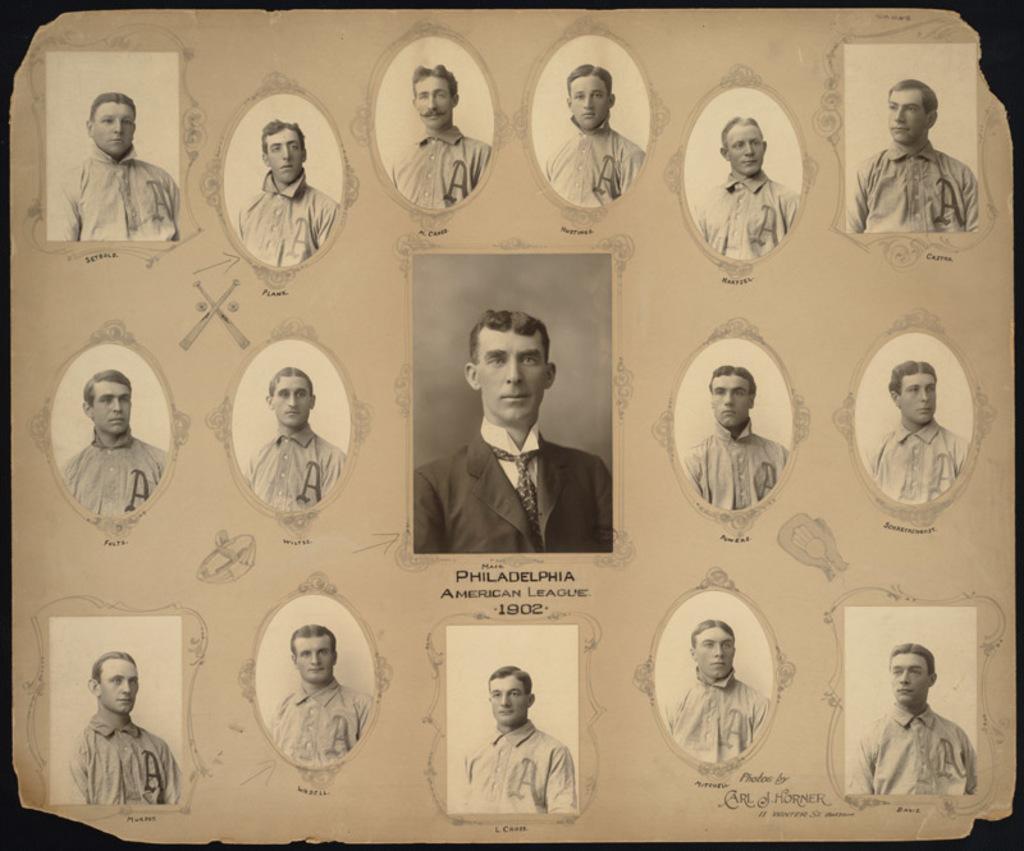In one or two sentences, can you explain what this image depicts? In the image we can see a paper, on the paper there are some photos. 